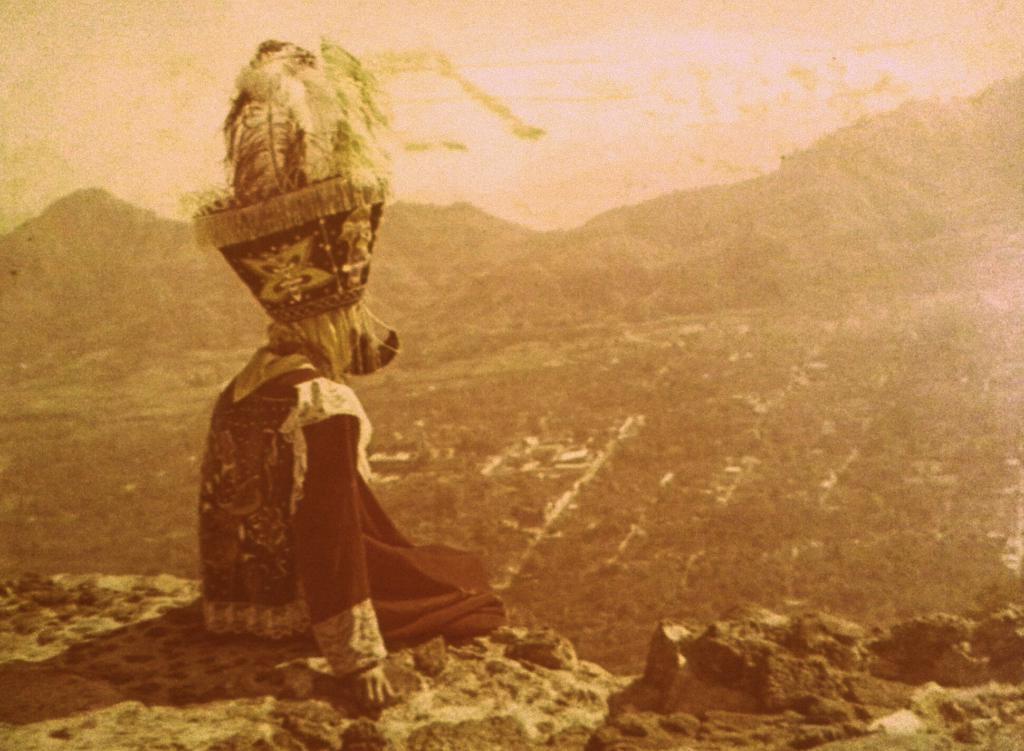Can you describe this image briefly? In this picture, we can see a person sitting, and we can see the ground, mountains, and the sky. 